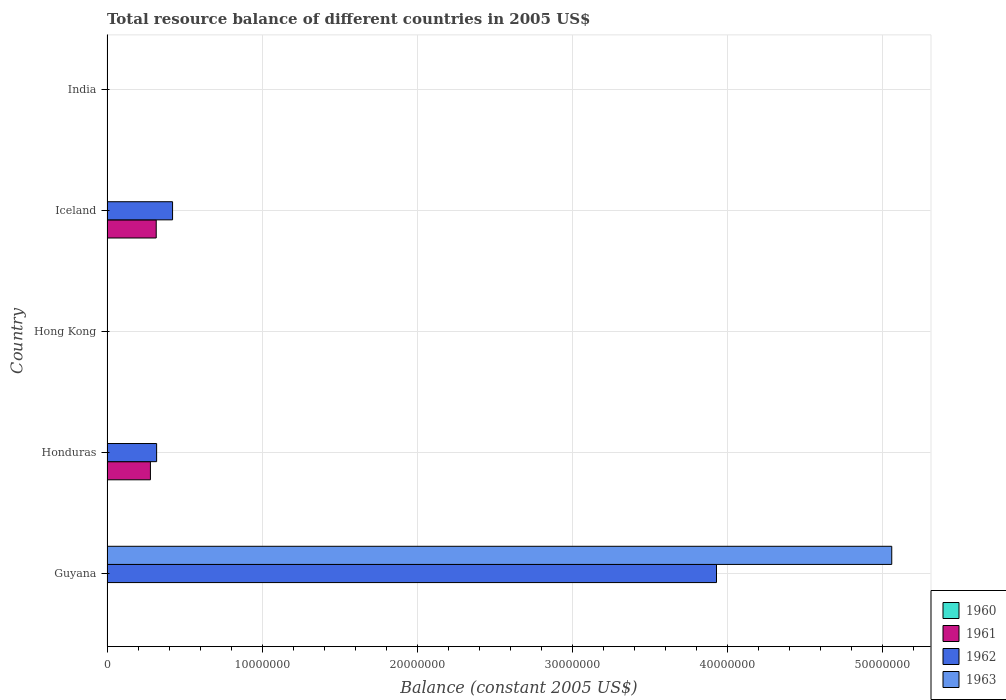How many bars are there on the 3rd tick from the bottom?
Offer a terse response. 0. What is the label of the 4th group of bars from the top?
Provide a short and direct response. Honduras. What is the total resource balance in 1963 in Guyana?
Your response must be concise. 5.06e+07. Across all countries, what is the maximum total resource balance in 1962?
Keep it short and to the point. 3.93e+07. In which country was the total resource balance in 1961 maximum?
Offer a very short reply. Iceland. What is the total total resource balance in 1962 in the graph?
Provide a succinct answer. 4.67e+07. What is the difference between the total resource balance in 1962 in Guyana and that in Honduras?
Provide a succinct answer. 3.61e+07. What is the difference between the total resource balance in 1963 in Guyana and the total resource balance in 1960 in India?
Ensure brevity in your answer.  5.06e+07. What is the average total resource balance in 1960 per country?
Keep it short and to the point. 0. What is the difference between the total resource balance in 1962 and total resource balance in 1963 in Guyana?
Make the answer very short. -1.13e+07. In how many countries, is the total resource balance in 1960 greater than 46000000 US$?
Offer a very short reply. 0. What is the difference between the highest and the second highest total resource balance in 1962?
Provide a succinct answer. 3.51e+07. What is the difference between the highest and the lowest total resource balance in 1961?
Make the answer very short. 3.17e+06. Is the sum of the total resource balance in 1962 in Guyana and Honduras greater than the maximum total resource balance in 1963 across all countries?
Keep it short and to the point. No. Is it the case that in every country, the sum of the total resource balance in 1960 and total resource balance in 1961 is greater than the total resource balance in 1962?
Keep it short and to the point. No. How many bars are there?
Provide a short and direct response. 6. Are all the bars in the graph horizontal?
Your answer should be compact. Yes. How many countries are there in the graph?
Make the answer very short. 5. What is the difference between two consecutive major ticks on the X-axis?
Your answer should be compact. 1.00e+07. Does the graph contain any zero values?
Give a very brief answer. Yes. How many legend labels are there?
Offer a very short reply. 4. How are the legend labels stacked?
Ensure brevity in your answer.  Vertical. What is the title of the graph?
Offer a very short reply. Total resource balance of different countries in 2005 US$. Does "1993" appear as one of the legend labels in the graph?
Ensure brevity in your answer.  No. What is the label or title of the X-axis?
Make the answer very short. Balance (constant 2005 US$). What is the label or title of the Y-axis?
Provide a short and direct response. Country. What is the Balance (constant 2005 US$) in 1960 in Guyana?
Give a very brief answer. 0. What is the Balance (constant 2005 US$) in 1961 in Guyana?
Your response must be concise. 0. What is the Balance (constant 2005 US$) in 1962 in Guyana?
Provide a short and direct response. 3.93e+07. What is the Balance (constant 2005 US$) of 1963 in Guyana?
Make the answer very short. 5.06e+07. What is the Balance (constant 2005 US$) in 1961 in Honduras?
Provide a succinct answer. 2.80e+06. What is the Balance (constant 2005 US$) in 1962 in Honduras?
Offer a terse response. 3.20e+06. What is the Balance (constant 2005 US$) of 1963 in Honduras?
Give a very brief answer. 0. What is the Balance (constant 2005 US$) of 1960 in Hong Kong?
Offer a very short reply. 0. What is the Balance (constant 2005 US$) of 1962 in Hong Kong?
Keep it short and to the point. 0. What is the Balance (constant 2005 US$) of 1960 in Iceland?
Make the answer very short. 0. What is the Balance (constant 2005 US$) in 1961 in Iceland?
Provide a short and direct response. 3.17e+06. What is the Balance (constant 2005 US$) in 1962 in Iceland?
Make the answer very short. 4.23e+06. What is the Balance (constant 2005 US$) in 1963 in Iceland?
Offer a terse response. 0. What is the Balance (constant 2005 US$) in 1962 in India?
Your answer should be compact. 0. What is the Balance (constant 2005 US$) in 1963 in India?
Keep it short and to the point. 0. Across all countries, what is the maximum Balance (constant 2005 US$) in 1961?
Your answer should be very brief. 3.17e+06. Across all countries, what is the maximum Balance (constant 2005 US$) in 1962?
Provide a succinct answer. 3.93e+07. Across all countries, what is the maximum Balance (constant 2005 US$) of 1963?
Provide a succinct answer. 5.06e+07. Across all countries, what is the minimum Balance (constant 2005 US$) in 1961?
Provide a succinct answer. 0. Across all countries, what is the minimum Balance (constant 2005 US$) of 1962?
Ensure brevity in your answer.  0. What is the total Balance (constant 2005 US$) in 1961 in the graph?
Offer a very short reply. 5.97e+06. What is the total Balance (constant 2005 US$) of 1962 in the graph?
Give a very brief answer. 4.67e+07. What is the total Balance (constant 2005 US$) in 1963 in the graph?
Your response must be concise. 5.06e+07. What is the difference between the Balance (constant 2005 US$) of 1962 in Guyana and that in Honduras?
Your response must be concise. 3.61e+07. What is the difference between the Balance (constant 2005 US$) of 1962 in Guyana and that in Iceland?
Give a very brief answer. 3.51e+07. What is the difference between the Balance (constant 2005 US$) of 1961 in Honduras and that in Iceland?
Your response must be concise. -3.74e+05. What is the difference between the Balance (constant 2005 US$) of 1962 in Honduras and that in Iceland?
Offer a very short reply. -1.03e+06. What is the difference between the Balance (constant 2005 US$) in 1961 in Honduras and the Balance (constant 2005 US$) in 1962 in Iceland?
Offer a terse response. -1.43e+06. What is the average Balance (constant 2005 US$) of 1961 per country?
Make the answer very short. 1.19e+06. What is the average Balance (constant 2005 US$) in 1962 per country?
Give a very brief answer. 9.35e+06. What is the average Balance (constant 2005 US$) in 1963 per country?
Your answer should be compact. 1.01e+07. What is the difference between the Balance (constant 2005 US$) in 1962 and Balance (constant 2005 US$) in 1963 in Guyana?
Provide a succinct answer. -1.13e+07. What is the difference between the Balance (constant 2005 US$) of 1961 and Balance (constant 2005 US$) of 1962 in Honduras?
Your answer should be very brief. -4.00e+05. What is the difference between the Balance (constant 2005 US$) of 1961 and Balance (constant 2005 US$) of 1962 in Iceland?
Your response must be concise. -1.05e+06. What is the ratio of the Balance (constant 2005 US$) of 1962 in Guyana to that in Honduras?
Keep it short and to the point. 12.28. What is the ratio of the Balance (constant 2005 US$) of 1962 in Guyana to that in Iceland?
Ensure brevity in your answer.  9.3. What is the ratio of the Balance (constant 2005 US$) of 1961 in Honduras to that in Iceland?
Your answer should be compact. 0.88. What is the ratio of the Balance (constant 2005 US$) of 1962 in Honduras to that in Iceland?
Your response must be concise. 0.76. What is the difference between the highest and the second highest Balance (constant 2005 US$) in 1962?
Your response must be concise. 3.51e+07. What is the difference between the highest and the lowest Balance (constant 2005 US$) in 1961?
Make the answer very short. 3.17e+06. What is the difference between the highest and the lowest Balance (constant 2005 US$) in 1962?
Your answer should be compact. 3.93e+07. What is the difference between the highest and the lowest Balance (constant 2005 US$) of 1963?
Ensure brevity in your answer.  5.06e+07. 